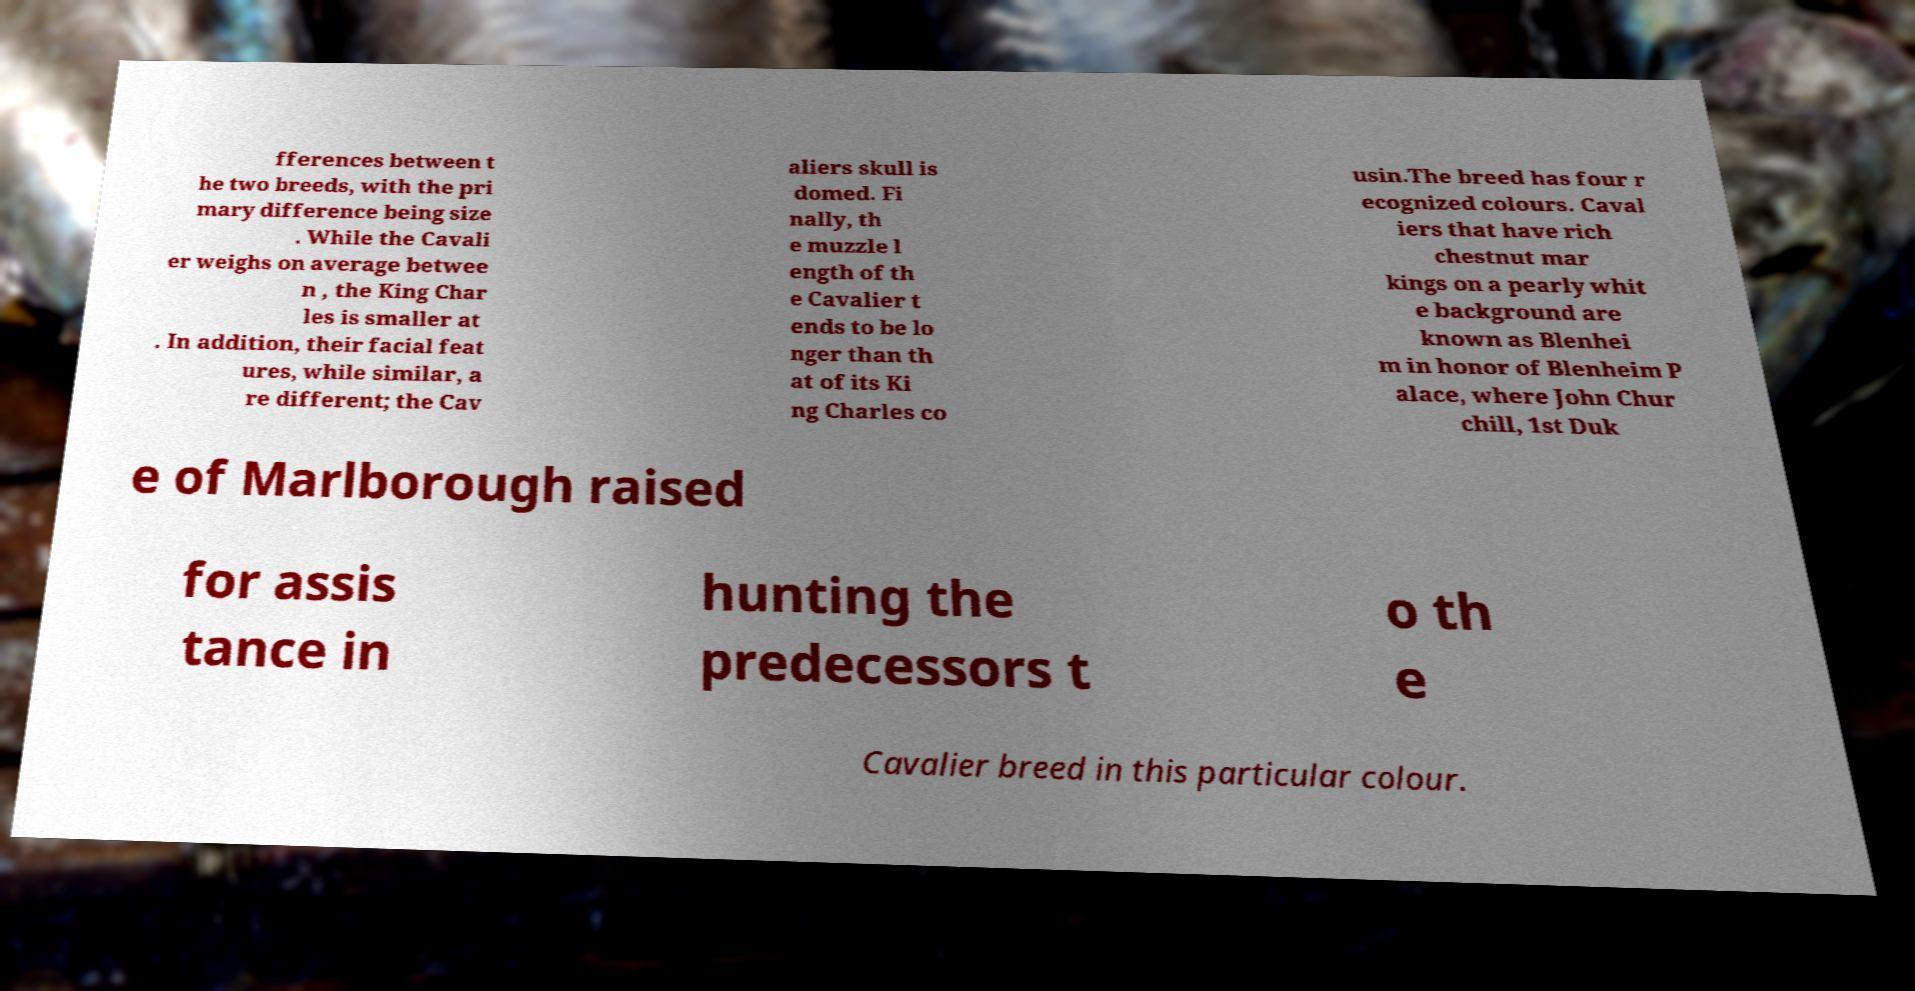Could you assist in decoding the text presented in this image and type it out clearly? fferences between t he two breeds, with the pri mary difference being size . While the Cavali er weighs on average betwee n , the King Char les is smaller at . In addition, their facial feat ures, while similar, a re different; the Cav aliers skull is domed. Fi nally, th e muzzle l ength of th e Cavalier t ends to be lo nger than th at of its Ki ng Charles co usin.The breed has four r ecognized colours. Caval iers that have rich chestnut mar kings on a pearly whit e background are known as Blenhei m in honor of Blenheim P alace, where John Chur chill, 1st Duk e of Marlborough raised for assis tance in hunting the predecessors t o th e Cavalier breed in this particular colour. 